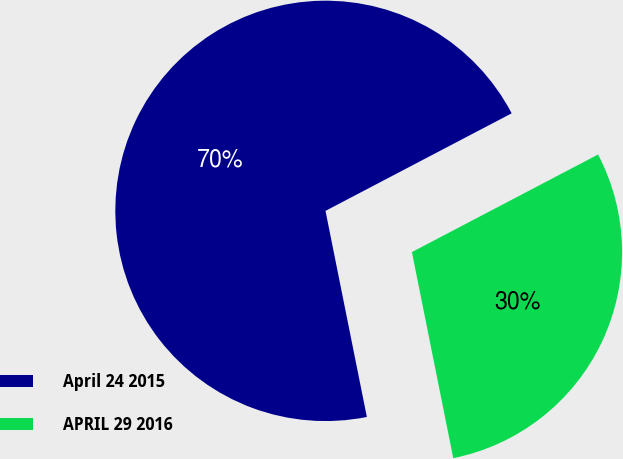Convert chart to OTSL. <chart><loc_0><loc_0><loc_500><loc_500><pie_chart><fcel>April 24 2015<fcel>APRIL 29 2016<nl><fcel>70.47%<fcel>29.53%<nl></chart> 